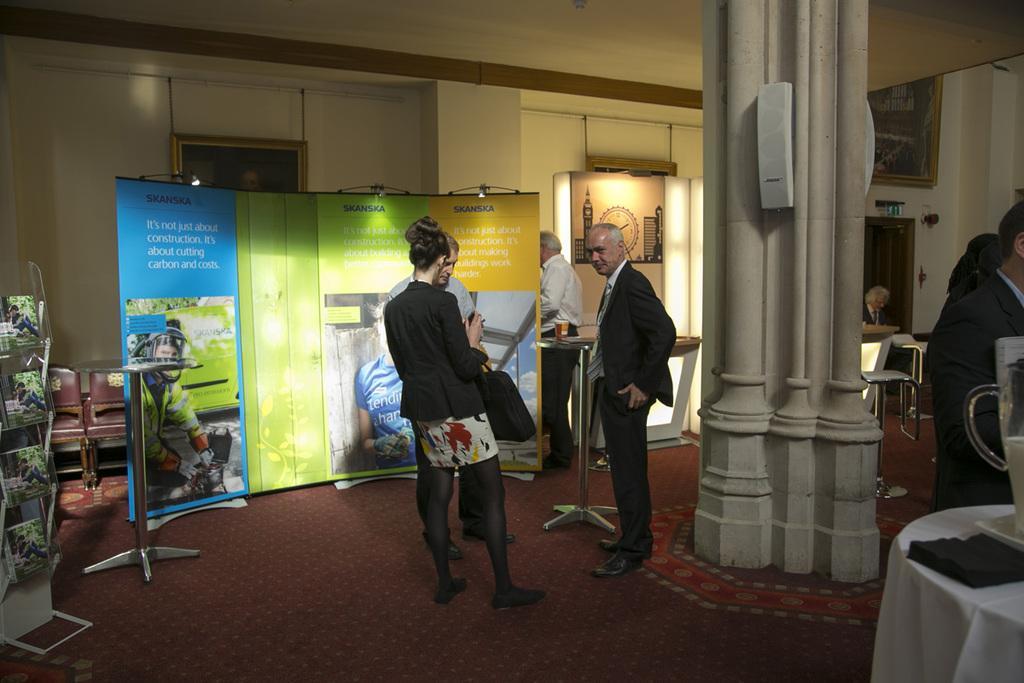Please provide a concise description of this image. This picture is clicked inside. On the right corner there is a table on the top of which some items are placed and we can see the persons standing on the ground. In the center we can see the group of people standing on the ground. On the left there is a cabinet containing books and we can see the chairs, table, banners on which the text is printed. In the background we can see the chairs, tables, pillar, wall, picture frames hanging on the wall and some other items. 